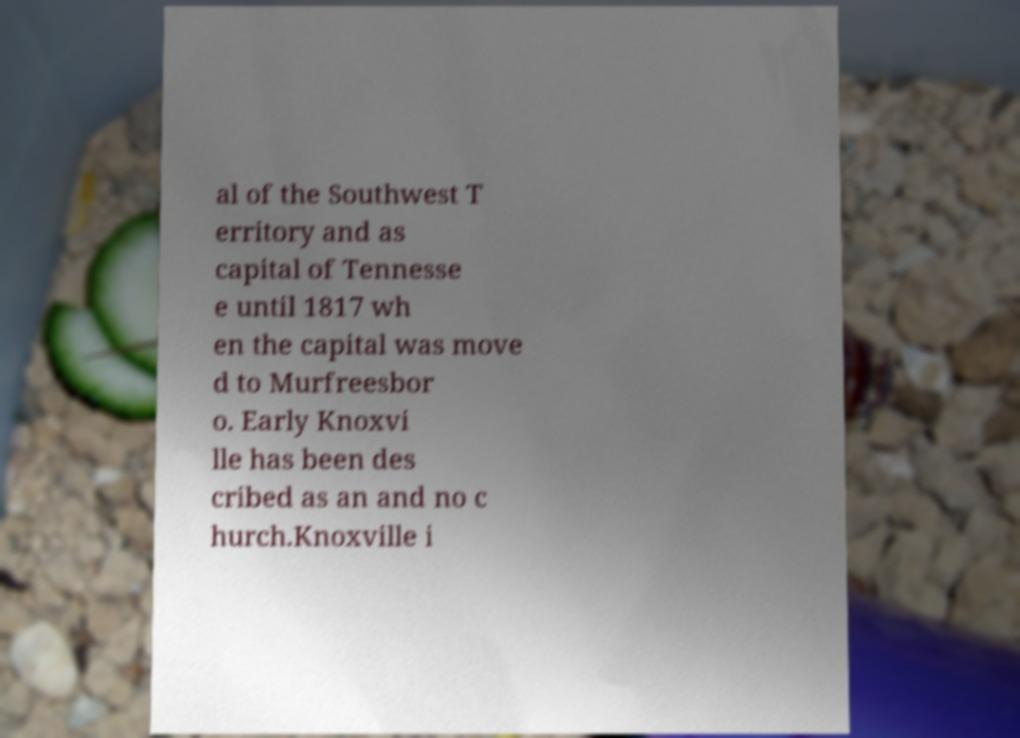Could you extract and type out the text from this image? al of the Southwest T erritory and as capital of Tennesse e until 1817 wh en the capital was move d to Murfreesbor o. Early Knoxvi lle has been des cribed as an and no c hurch.Knoxville i 